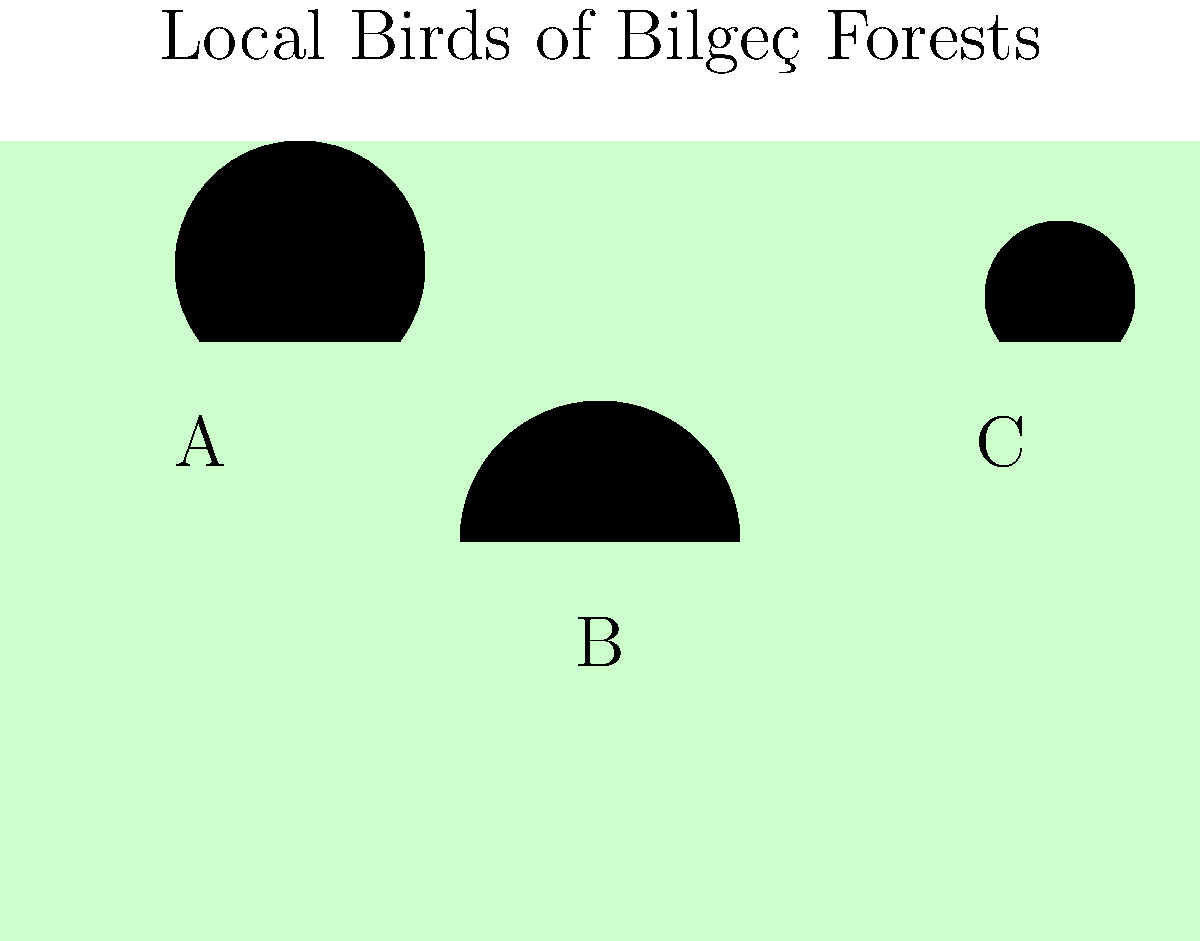Based on the silhouettes shown in the image, which bird is most likely to be the White Stork (Leylek), a common sight in Bilgeç forests during spring and summer? To identify the White Stork from the given silhouettes, let's analyze each bird's characteristics:

1. Bird A: This silhouette shows a bird with a long neck and legs, which are characteristic features of the White Stork. The body shape is elongated, and the beak appears long and straight.

2. Bird B: This silhouette depicts a bird with a round head and body, likely representing an owl. The shape is more compact and lacks the long neck and legs of a stork.

3. Bird C: This silhouette shows a bird with a distinctively shaped head and beak, probably representing a woodpecker. The body is smaller and more compact compared to a stork.

The White Stork (Leylek) is known for its tall stature, long neck, and long legs. These features are most prominently displayed in the silhouette of Bird A. As a proud villager from Bilgeç, you would be familiar with the sight of these majestic birds in your local forests during the warmer months.

Therefore, based on the characteristics observed in the silhouettes, Bird A is most likely to represent the White Stork (Leylek).
Answer: A 